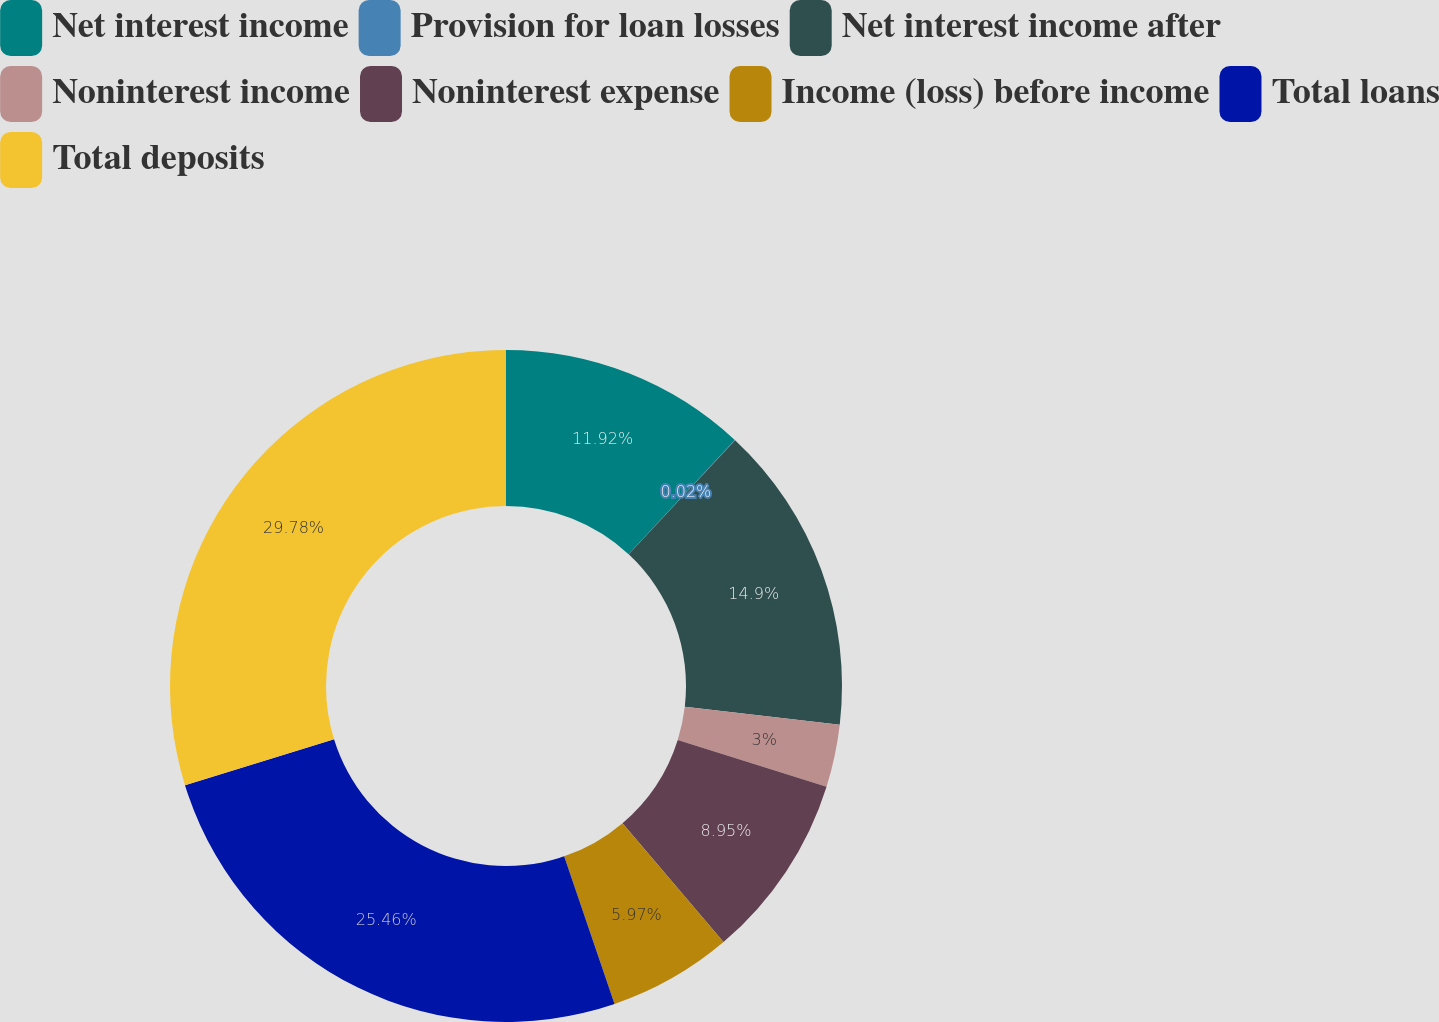Convert chart. <chart><loc_0><loc_0><loc_500><loc_500><pie_chart><fcel>Net interest income<fcel>Provision for loan losses<fcel>Net interest income after<fcel>Noninterest income<fcel>Noninterest expense<fcel>Income (loss) before income<fcel>Total loans<fcel>Total deposits<nl><fcel>11.92%<fcel>0.02%<fcel>14.9%<fcel>3.0%<fcel>8.95%<fcel>5.97%<fcel>25.46%<fcel>29.77%<nl></chart> 